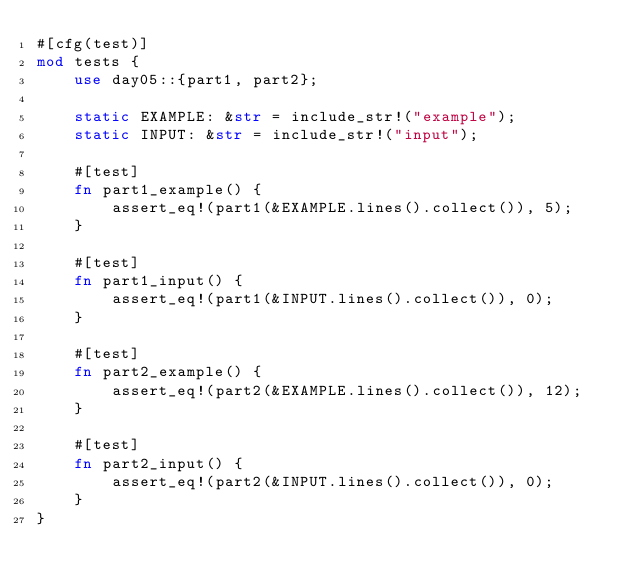<code> <loc_0><loc_0><loc_500><loc_500><_Rust_>#[cfg(test)]
mod tests {
    use day05::{part1, part2};

    static EXAMPLE: &str = include_str!("example");
    static INPUT: &str = include_str!("input");

    #[test]
    fn part1_example() {
        assert_eq!(part1(&EXAMPLE.lines().collect()), 5);
    }

    #[test]
    fn part1_input() {
        assert_eq!(part1(&INPUT.lines().collect()), 0);
    }

    #[test]
    fn part2_example() {
        assert_eq!(part2(&EXAMPLE.lines().collect()), 12);
    }

    #[test]
    fn part2_input() {
        assert_eq!(part2(&INPUT.lines().collect()), 0);
    }
}
</code> 